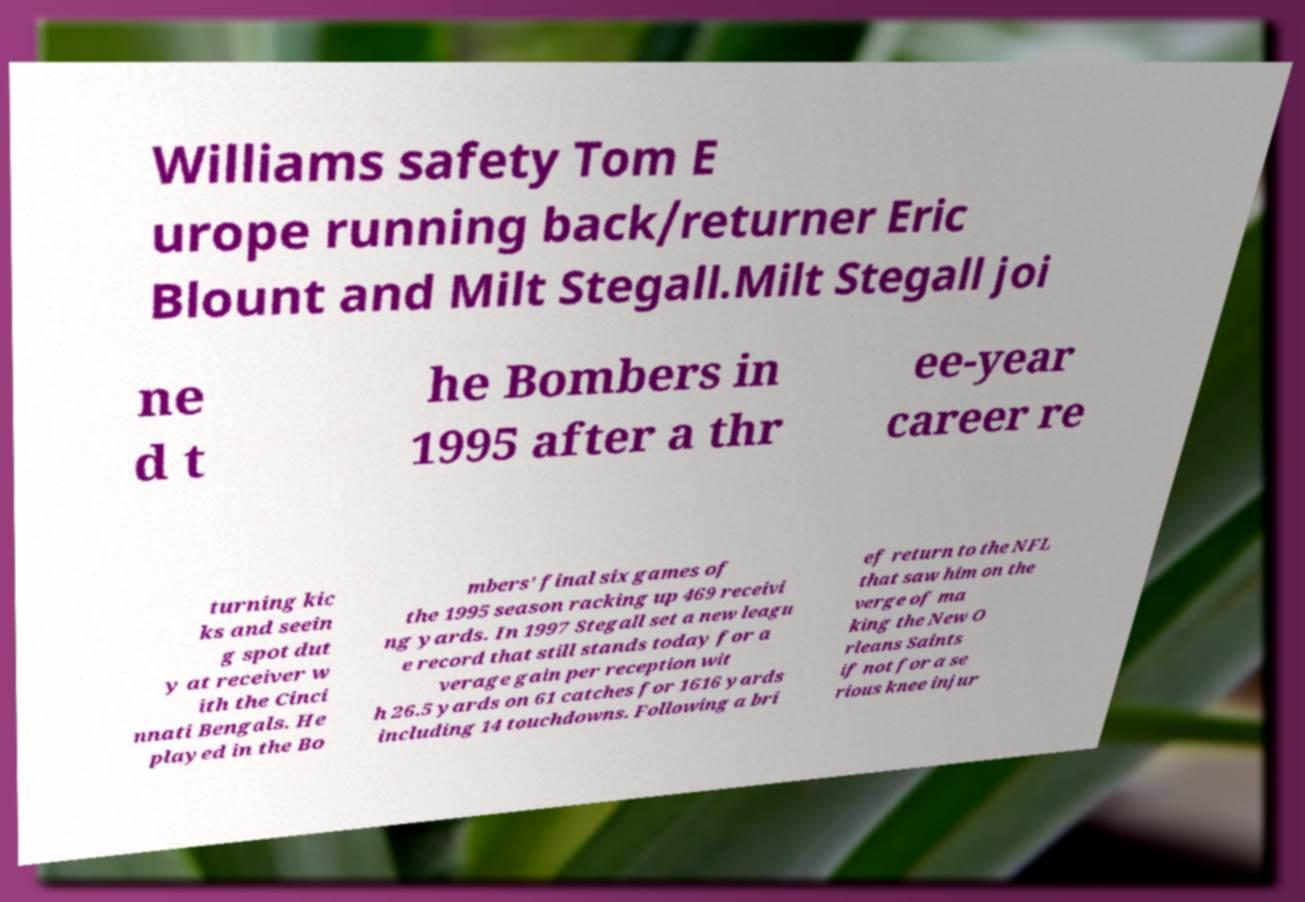Please identify and transcribe the text found in this image. Williams safety Tom E urope running back/returner Eric Blount and Milt Stegall.Milt Stegall joi ne d t he Bombers in 1995 after a thr ee-year career re turning kic ks and seein g spot dut y at receiver w ith the Cinci nnati Bengals. He played in the Bo mbers' final six games of the 1995 season racking up 469 receivi ng yards. In 1997 Stegall set a new leagu e record that still stands today for a verage gain per reception wit h 26.5 yards on 61 catches for 1616 yards including 14 touchdowns. Following a bri ef return to the NFL that saw him on the verge of ma king the New O rleans Saints if not for a se rious knee injur 